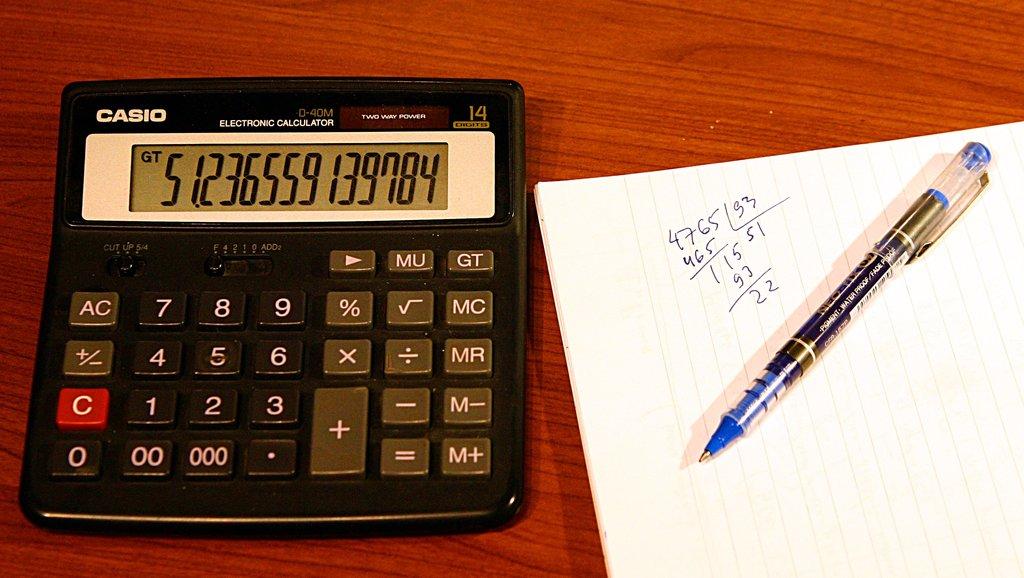What is the number located on the calculators screen?
Make the answer very short. 51.236559139784. What brand is the calculator?
Keep it short and to the point. Casio. 